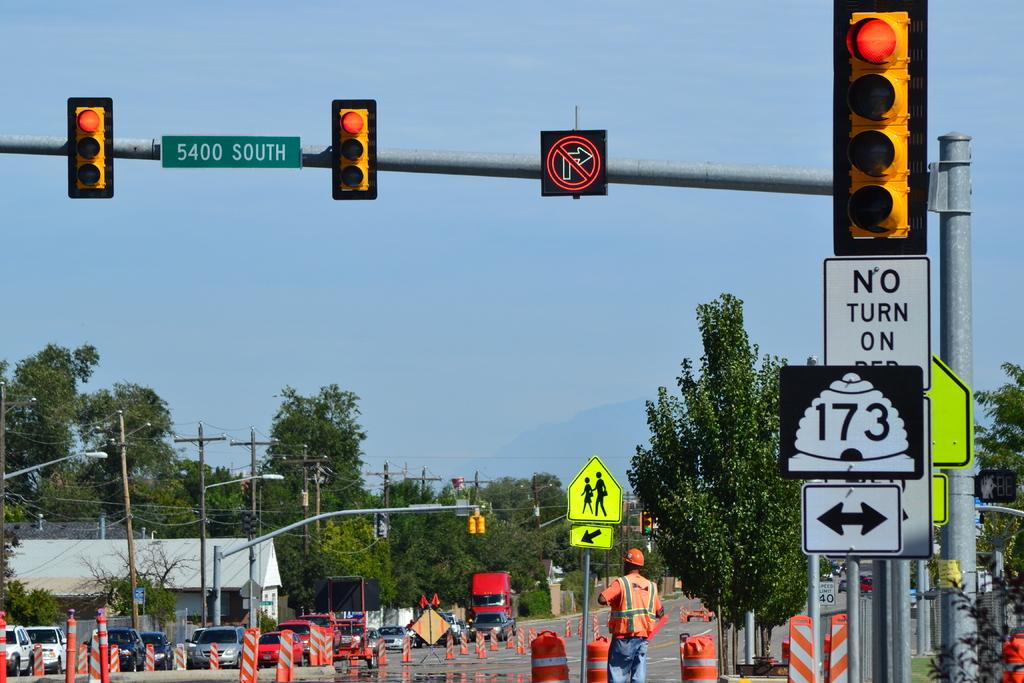<image>
Share a concise interpretation of the image provided. A construction zone that is set up near 5400 South. 